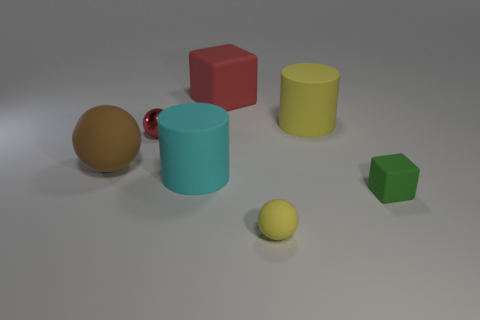What material is the other thing that is the same color as the metal thing?
Your response must be concise. Rubber. How many other things are there of the same color as the big block?
Make the answer very short. 1. There is a yellow matte object behind the ball on the right side of the large matte cylinder left of the red rubber block; how big is it?
Offer a very short reply. Large. There is a cyan matte cylinder; are there any small matte blocks behind it?
Your response must be concise. No. There is a red sphere; does it have the same size as the yellow rubber object that is behind the cyan rubber thing?
Offer a very short reply. No. What number of other objects are the same material as the tiny red thing?
Provide a short and direct response. 0. There is a rubber object that is both to the right of the big sphere and left of the big red rubber cube; what is its shape?
Provide a short and direct response. Cylinder. Is the size of the yellow rubber object behind the brown ball the same as the yellow rubber thing in front of the red ball?
Provide a succinct answer. No. There is a green object that is made of the same material as the red block; what shape is it?
Make the answer very short. Cube. Are there any other things that have the same shape as the shiny object?
Offer a very short reply. Yes. 